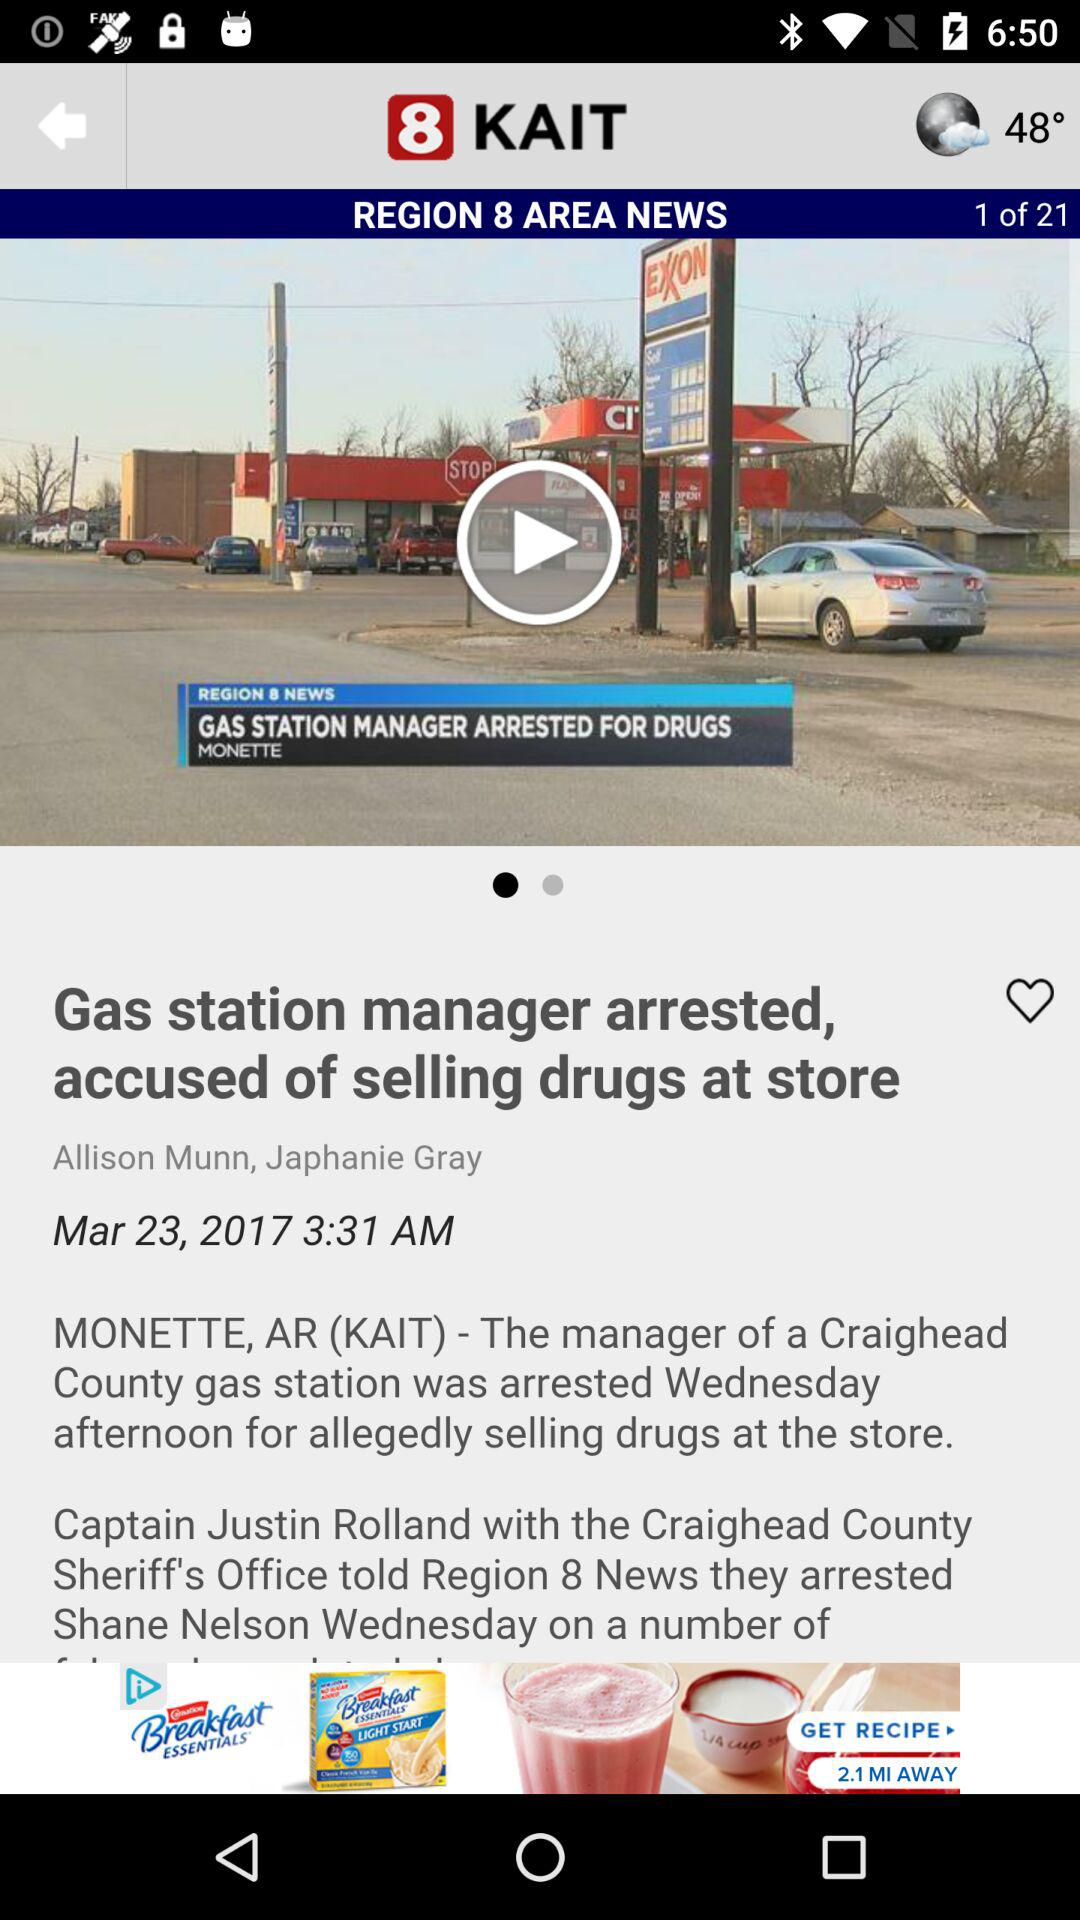What is the temperature? The temperature is 48°. 